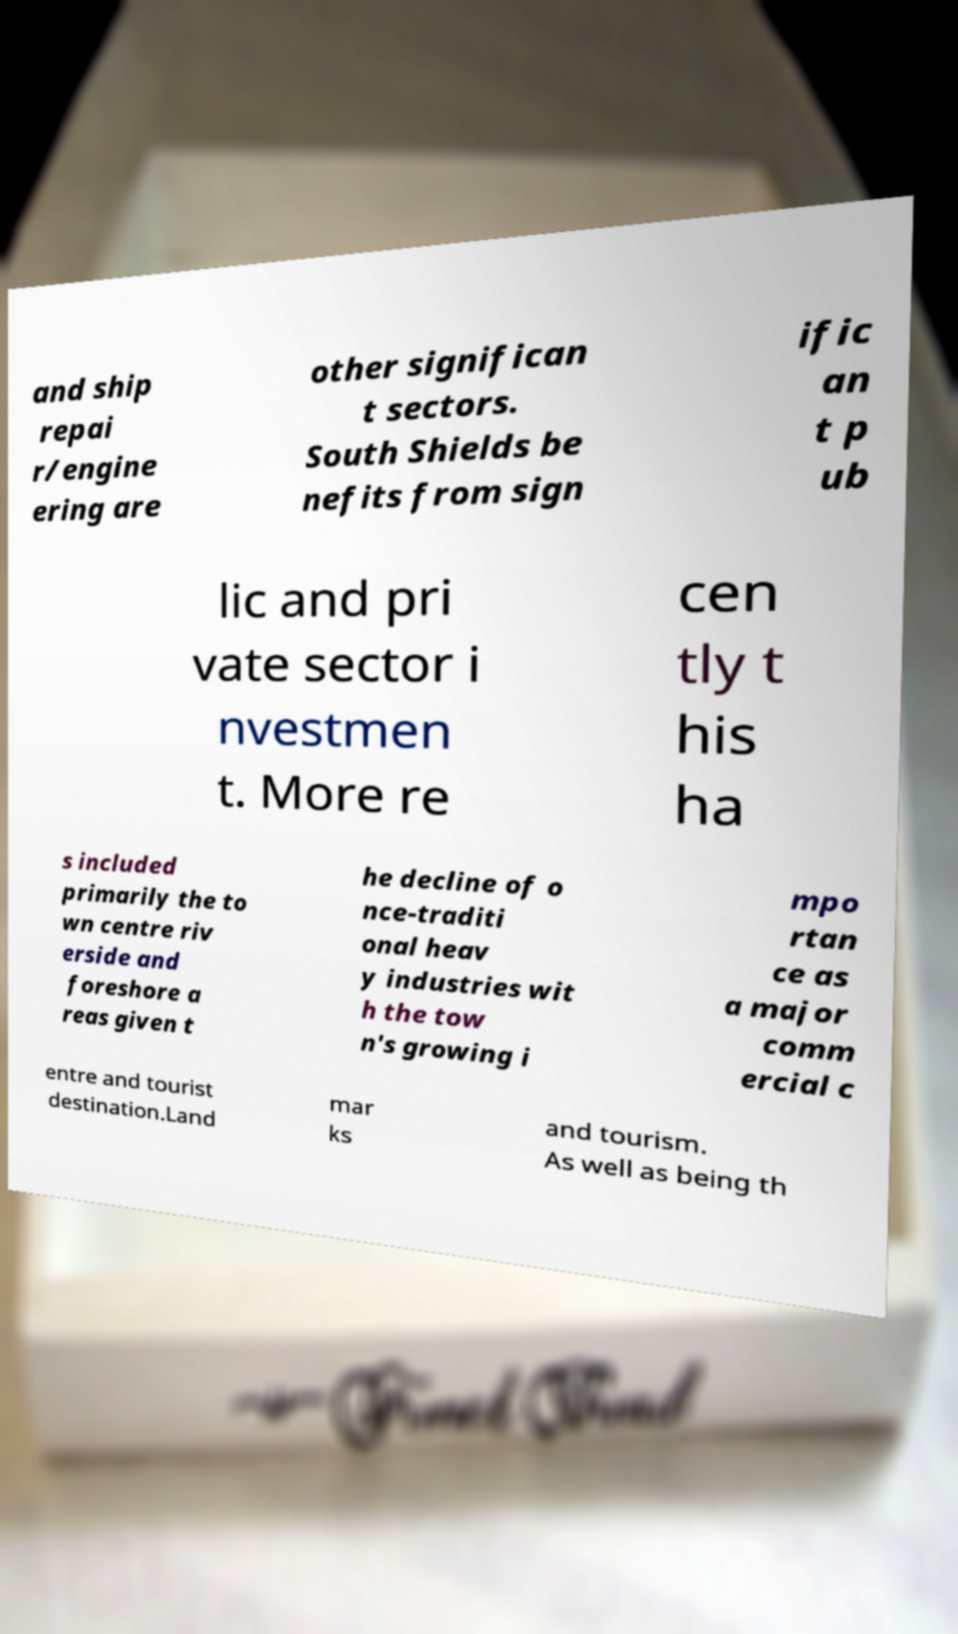There's text embedded in this image that I need extracted. Can you transcribe it verbatim? and ship repai r/engine ering are other significan t sectors. South Shields be nefits from sign ific an t p ub lic and pri vate sector i nvestmen t. More re cen tly t his ha s included primarily the to wn centre riv erside and foreshore a reas given t he decline of o nce-traditi onal heav y industries wit h the tow n's growing i mpo rtan ce as a major comm ercial c entre and tourist destination.Land mar ks and tourism. As well as being th 